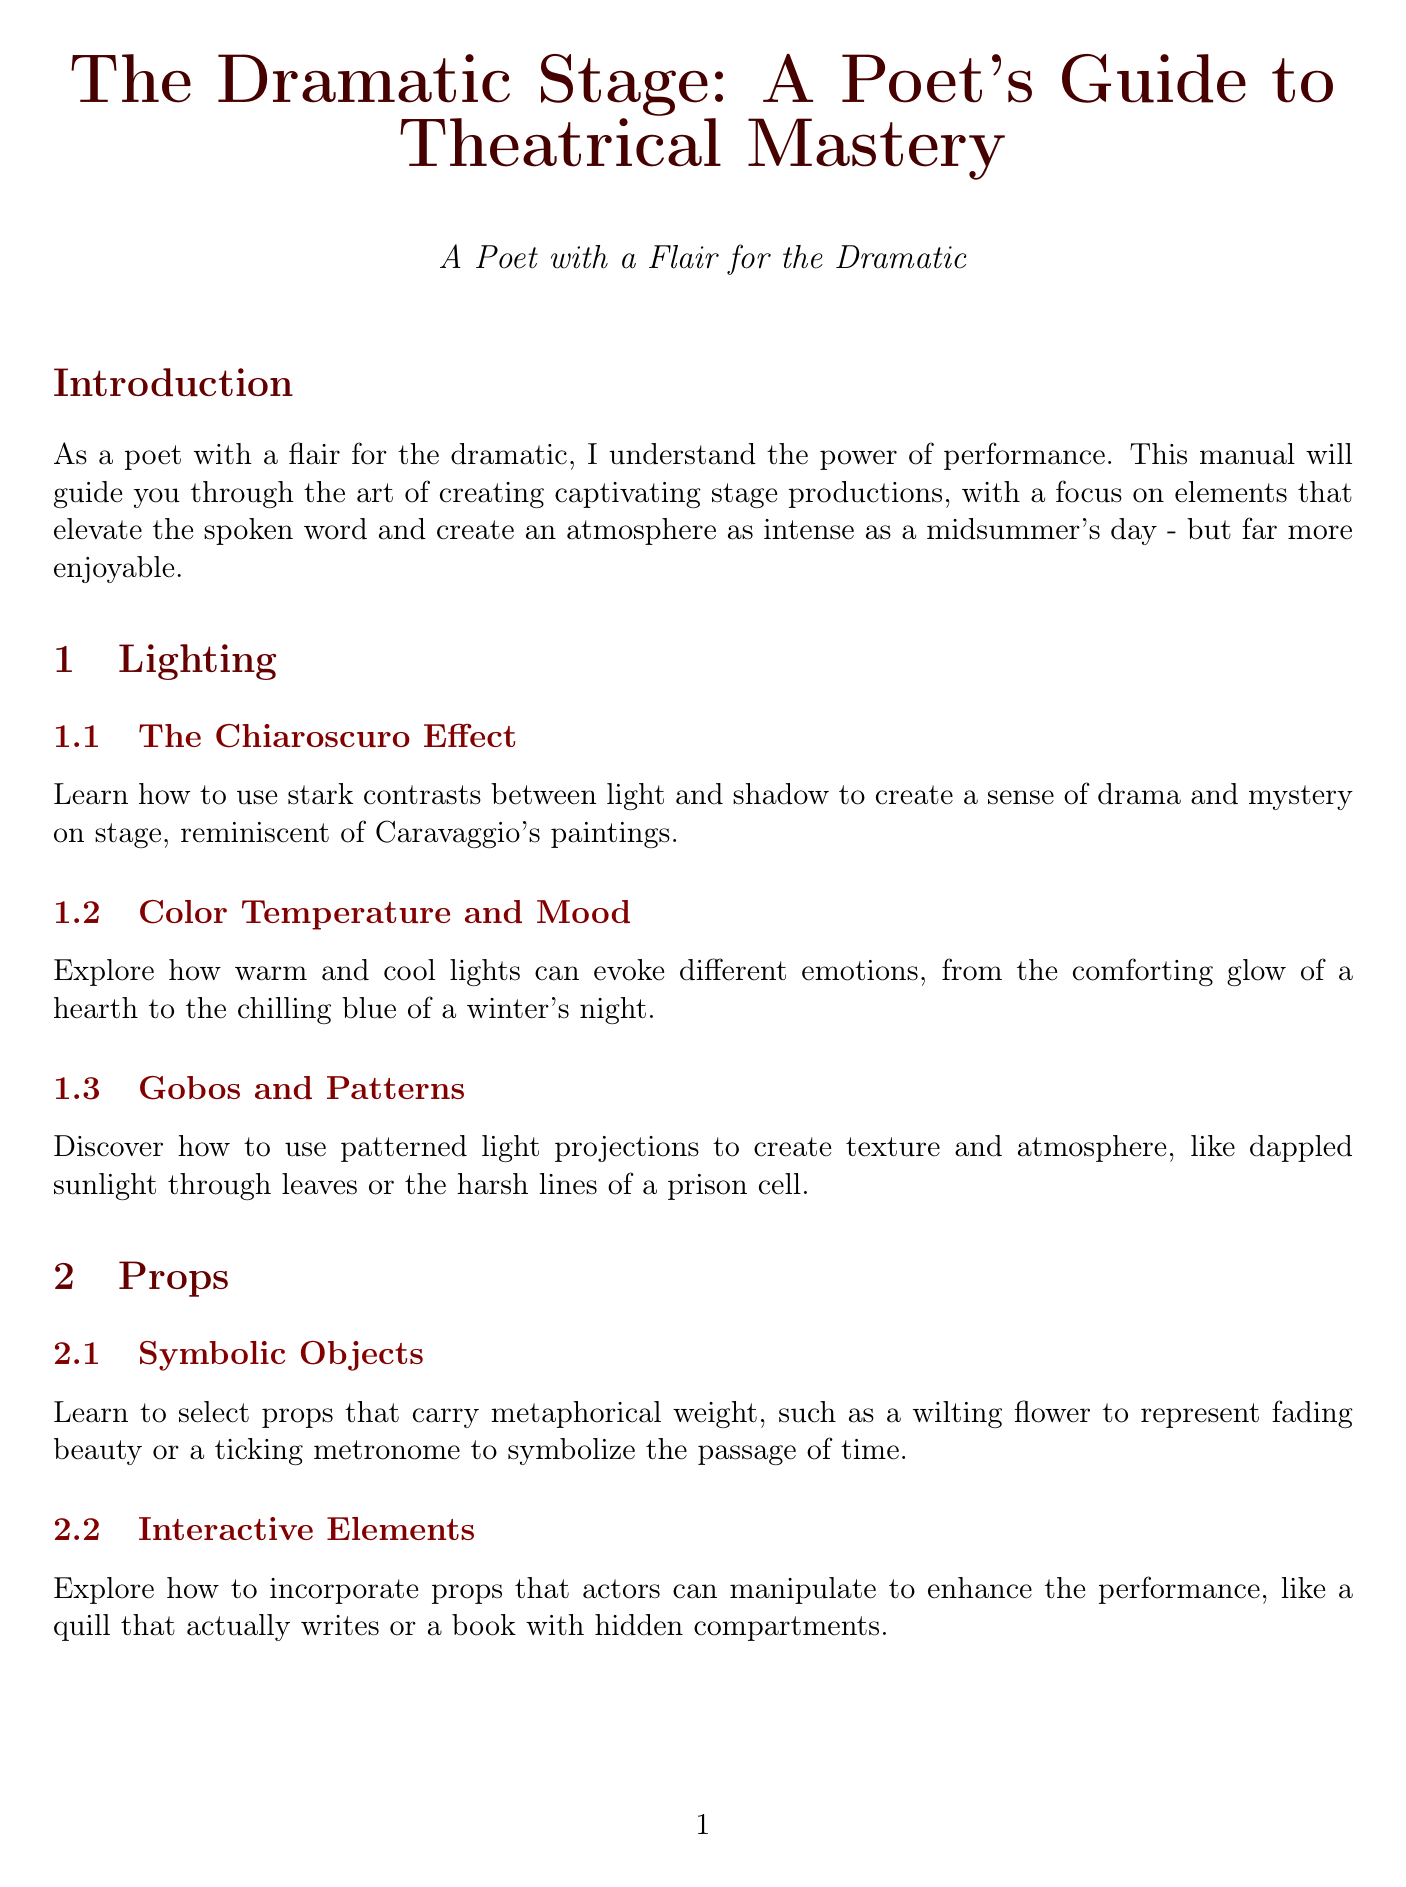What is the title of the manual? The title is mentioned at the beginning of the document.
Answer: The Dramatic Stage: A Poet's Guide to Theatrical Mastery How many sections are there in the manual? The document lists multiple sections including Lighting, Props, Voice Projection, etc.
Answer: 6 What is the main focus of the Lighting section? The Lighting section encompasses various techniques and effects related to stage lighting.
Answer: Techniques and effects What technique is used to create contrasts between light and shadow? The specific technique is indicated in the related subsection in the Lighting section.
Answer: The Chiaroscuro Effect What is the purpose of symbolic objects in props? The document explains their role in enhancing the metaphorical weight of performances.
Answer: Metaphorical weight What should be maintained to beat the heat under stage lights? The document emphasizes the importance of composure during performances in the heat.
Answer: Composure Which type of optimization is discussed in the Environmental Considerations? The document specifies how to work with venue acoustics.
Answer: Acoustic Optimization Which poetic technique involves synchronizing movements with meter? This technique is outlined in the Poetic Integration section.
Answer: Rhythmic Blocking What emotional states should be conveyed through voice projection? The document highlights various emotional modulations actors can express.
Answer: Raw emotion 